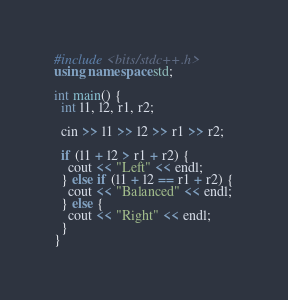<code> <loc_0><loc_0><loc_500><loc_500><_C++_>#include <bits/stdc++.h>
using namespace std;

int main() {
  int l1, l2, r1, r2;
  
  cin >> l1 >> l2 >> r1 >> r2;
  
  if (l1 + l2 > r1 + r2) {
    cout << "Left" << endl;
  } else if (l1 + l2 == r1 + r2) {
    cout << "Balanced" << endl;
  } else {
    cout << "Right" << endl;
  }
}</code> 